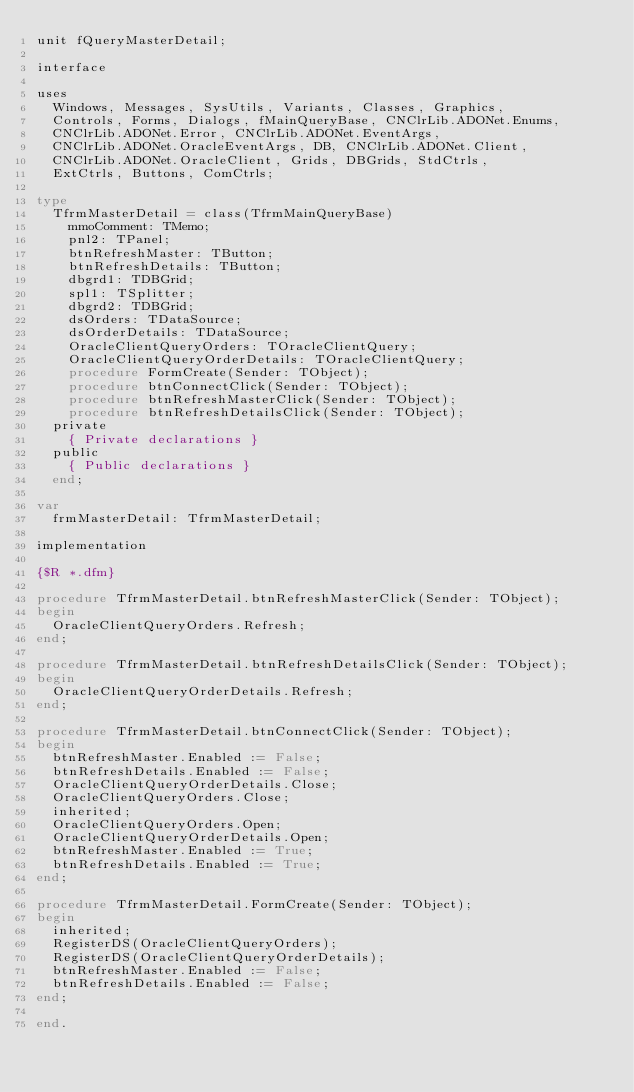<code> <loc_0><loc_0><loc_500><loc_500><_Pascal_>unit fQueryMasterDetail;

interface

uses
  Windows, Messages, SysUtils, Variants, Classes, Graphics,
  Controls, Forms, Dialogs, fMainQueryBase, CNClrLib.ADONet.Enums,
  CNClrLib.ADONet.Error, CNClrLib.ADONet.EventArgs,
  CNClrLib.ADONet.OracleEventArgs, DB, CNClrLib.ADONet.Client,
  CNClrLib.ADONet.OracleClient, Grids, DBGrids, StdCtrls,
  ExtCtrls, Buttons, ComCtrls;

type
  TfrmMasterDetail = class(TfrmMainQueryBase)
    mmoComment: TMemo;
    pnl2: TPanel;
    btnRefreshMaster: TButton;
    btnRefreshDetails: TButton;
    dbgrd1: TDBGrid;
    spl1: TSplitter;
    dbgrd2: TDBGrid;
    dsOrders: TDataSource;
    dsOrderDetails: TDataSource;
    OracleClientQueryOrders: TOracleClientQuery;
    OracleClientQueryOrderDetails: TOracleClientQuery;
    procedure FormCreate(Sender: TObject);
    procedure btnConnectClick(Sender: TObject);
    procedure btnRefreshMasterClick(Sender: TObject);
    procedure btnRefreshDetailsClick(Sender: TObject);
  private
    { Private declarations }
  public
    { Public declarations }
  end;

var
  frmMasterDetail: TfrmMasterDetail;

implementation

{$R *.dfm}

procedure TfrmMasterDetail.btnRefreshMasterClick(Sender: TObject);
begin
  OracleClientQueryOrders.Refresh;
end;

procedure TfrmMasterDetail.btnRefreshDetailsClick(Sender: TObject);
begin
  OracleClientQueryOrderDetails.Refresh;
end;

procedure TfrmMasterDetail.btnConnectClick(Sender: TObject);
begin
  btnRefreshMaster.Enabled := False;
  btnRefreshDetails.Enabled := False;
  OracleClientQueryOrderDetails.Close;
  OracleClientQueryOrders.Close;
  inherited;
  OracleClientQueryOrders.Open;
  OracleClientQueryOrderDetails.Open;
  btnRefreshMaster.Enabled := True;
  btnRefreshDetails.Enabled := True;
end;

procedure TfrmMasterDetail.FormCreate(Sender: TObject);
begin
  inherited;
  RegisterDS(OracleClientQueryOrders);
  RegisterDS(OracleClientQueryOrderDetails);
  btnRefreshMaster.Enabled := False;
  btnRefreshDetails.Enabled := False;
end;

end.
</code> 